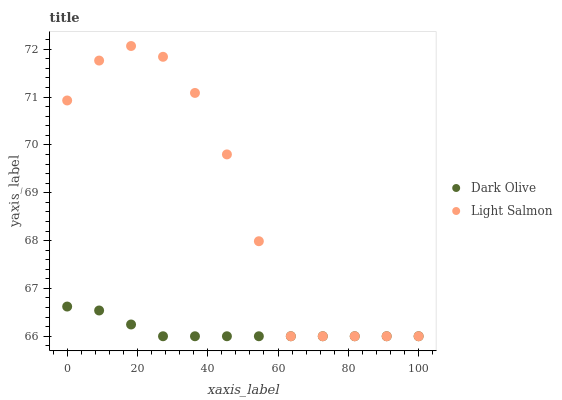Does Dark Olive have the minimum area under the curve?
Answer yes or no. Yes. Does Light Salmon have the maximum area under the curve?
Answer yes or no. Yes. Does Dark Olive have the maximum area under the curve?
Answer yes or no. No. Is Dark Olive the smoothest?
Answer yes or no. Yes. Is Light Salmon the roughest?
Answer yes or no. Yes. Is Dark Olive the roughest?
Answer yes or no. No. Does Light Salmon have the lowest value?
Answer yes or no. Yes. Does Light Salmon have the highest value?
Answer yes or no. Yes. Does Dark Olive have the highest value?
Answer yes or no. No. Does Light Salmon intersect Dark Olive?
Answer yes or no. Yes. Is Light Salmon less than Dark Olive?
Answer yes or no. No. Is Light Salmon greater than Dark Olive?
Answer yes or no. No. 